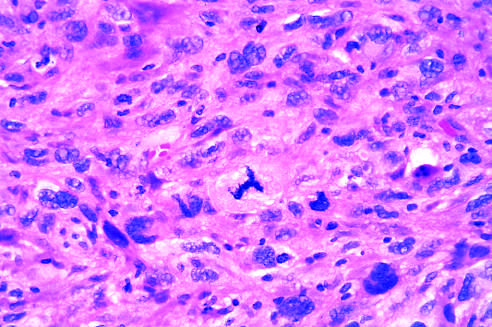what has an abnormal tripolar spindle?
Answer the question using a single word or phrase. The prominent cell in the center field 